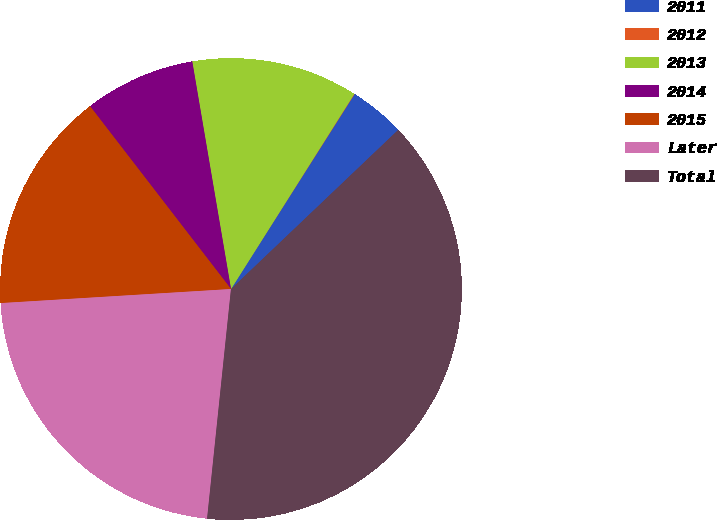Convert chart to OTSL. <chart><loc_0><loc_0><loc_500><loc_500><pie_chart><fcel>2011<fcel>2012<fcel>2013<fcel>2014<fcel>2015<fcel>Later<fcel>Total<nl><fcel>3.9%<fcel>0.03%<fcel>11.65%<fcel>7.77%<fcel>15.52%<fcel>22.38%<fcel>38.76%<nl></chart> 